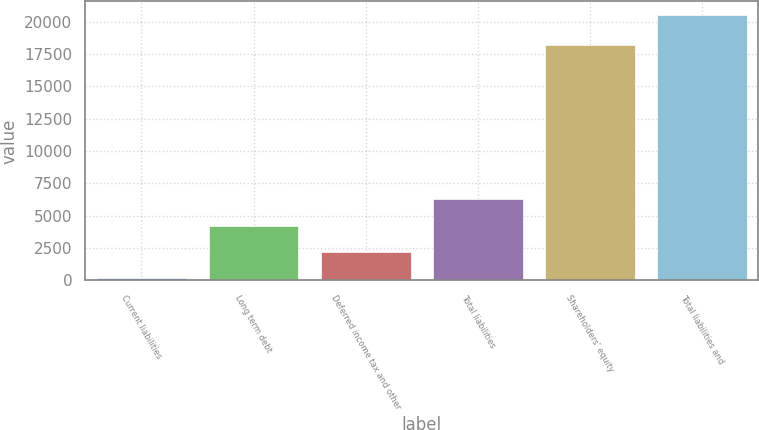<chart> <loc_0><loc_0><loc_500><loc_500><bar_chart><fcel>Current liabilities<fcel>Long term debt<fcel>Deferred income tax and other<fcel>Total liabilities<fcel>Shareholders' equity<fcel>Total liabilities and<nl><fcel>140<fcel>4218<fcel>2179<fcel>6257<fcel>18163<fcel>20530<nl></chart> 